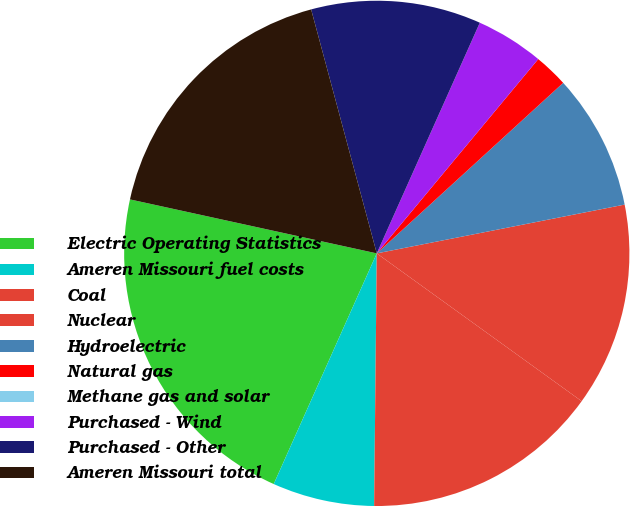Convert chart to OTSL. <chart><loc_0><loc_0><loc_500><loc_500><pie_chart><fcel>Electric Operating Statistics<fcel>Ameren Missouri fuel costs<fcel>Coal<fcel>Nuclear<fcel>Hydroelectric<fcel>Natural gas<fcel>Methane gas and solar<fcel>Purchased - Wind<fcel>Purchased - Other<fcel>Ameren Missouri total<nl><fcel>21.74%<fcel>6.52%<fcel>15.22%<fcel>13.04%<fcel>8.7%<fcel>2.17%<fcel>0.0%<fcel>4.35%<fcel>10.87%<fcel>17.39%<nl></chart> 